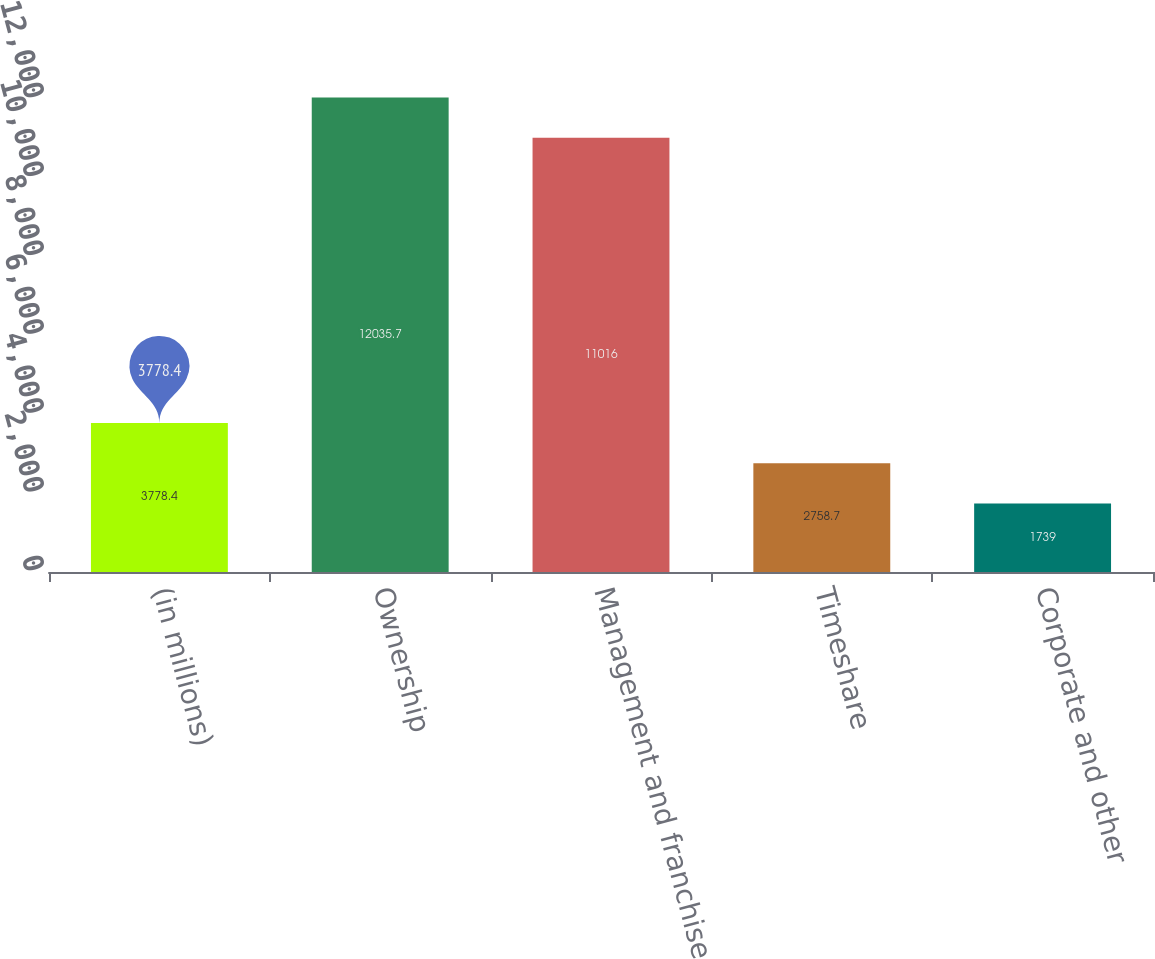<chart> <loc_0><loc_0><loc_500><loc_500><bar_chart><fcel>(in millions)<fcel>Ownership<fcel>Management and franchise<fcel>Timeshare<fcel>Corporate and other<nl><fcel>3778.4<fcel>12035.7<fcel>11016<fcel>2758.7<fcel>1739<nl></chart> 